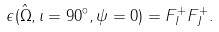Convert formula to latex. <formula><loc_0><loc_0><loc_500><loc_500>\epsilon ( \hat { \Omega } , \iota = 9 0 ^ { \circ } , \psi = 0 ) = F _ { I } ^ { + } F _ { J } ^ { + } .</formula> 